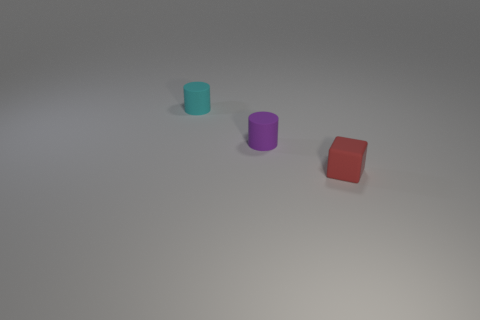Add 3 gray things. How many objects exist? 6 Subtract all cubes. How many objects are left? 2 Subtract 0 yellow spheres. How many objects are left? 3 Subtract all small cyan matte cylinders. Subtract all small cyan cylinders. How many objects are left? 1 Add 2 small red things. How many small red things are left? 3 Add 1 small matte things. How many small matte things exist? 4 